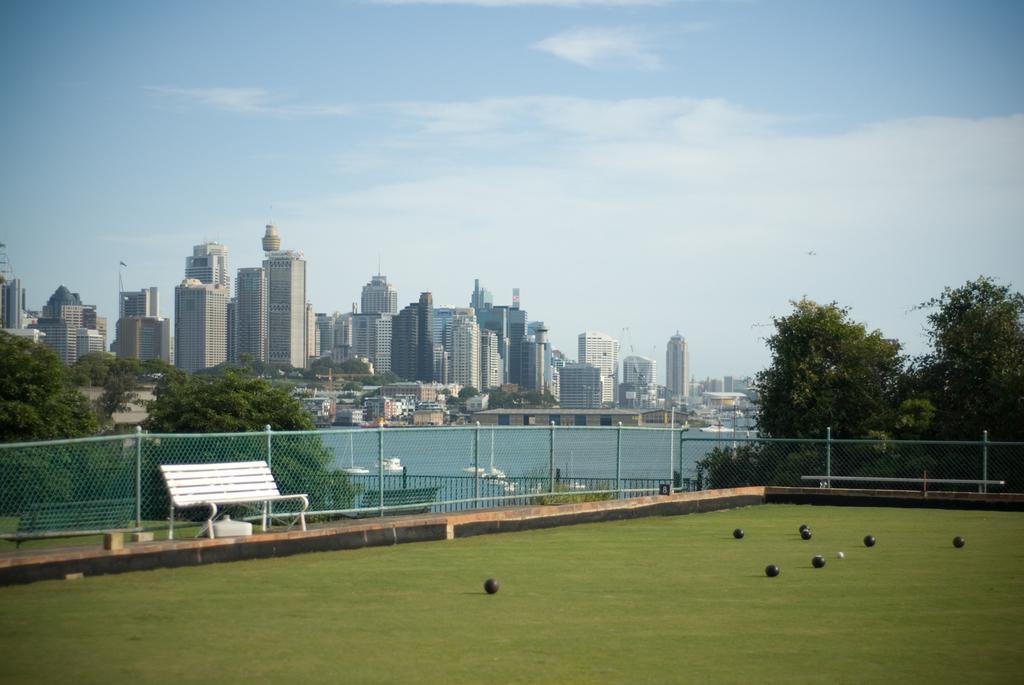Could you give a brief overview of what you see in this image? In the image I can see a place where we have a bench and balls on the ground and also I can see some buildings, fencing, trees and a lake in between. 